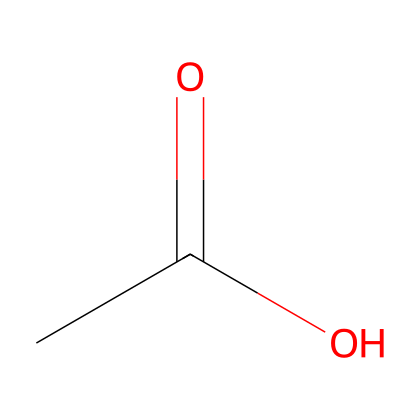What is the name of this chemical? The provided SMILES representation (CC(=O)O) corresponds to acetic acid, which is commonly known as vinegar. This is identified by recognizing the acetate group in the structure.
Answer: acetic acid How many carbon atoms are present in this structure? In the SMILES representation (CC(=O)O), there are two carbon atoms: one in the CH3 group and one in the carbonyl (C=O) group. This gives a total of two carbon atoms.
Answer: two What functional group is present in this chemical? The chemical structure has a carboxylic acid functional group, which is indicated by the presence of the –COOH part in the SMILES (CC(=O)O). This defines it as an acid.
Answer: carboxylic acid What is the total number of hydrogen atoms in this molecule? Analyzing the structure, there are three hydrogens attached to the CH3 group and one hydrogen in the -COOH group, giving a total of four hydrogen atoms: 3 from methyl and 1 from the carboxyl group.
Answer: four Is this chemical considered a weak acid or a strong acid? Acetic acid is a weak acid as it does not completely dissociate in water, which is a key characteristic of weak acids. This conclusion is based on the knowledge of acid dissociation properties.
Answer: weak acid What is one common use of this chemical in cooking? Acetic acid, or vinegar, is commonly used in cooking for flavoring and preserving foods. This is based on its historical and prevalent use in various recipes and food preservation practices.
Answer: flavoring 